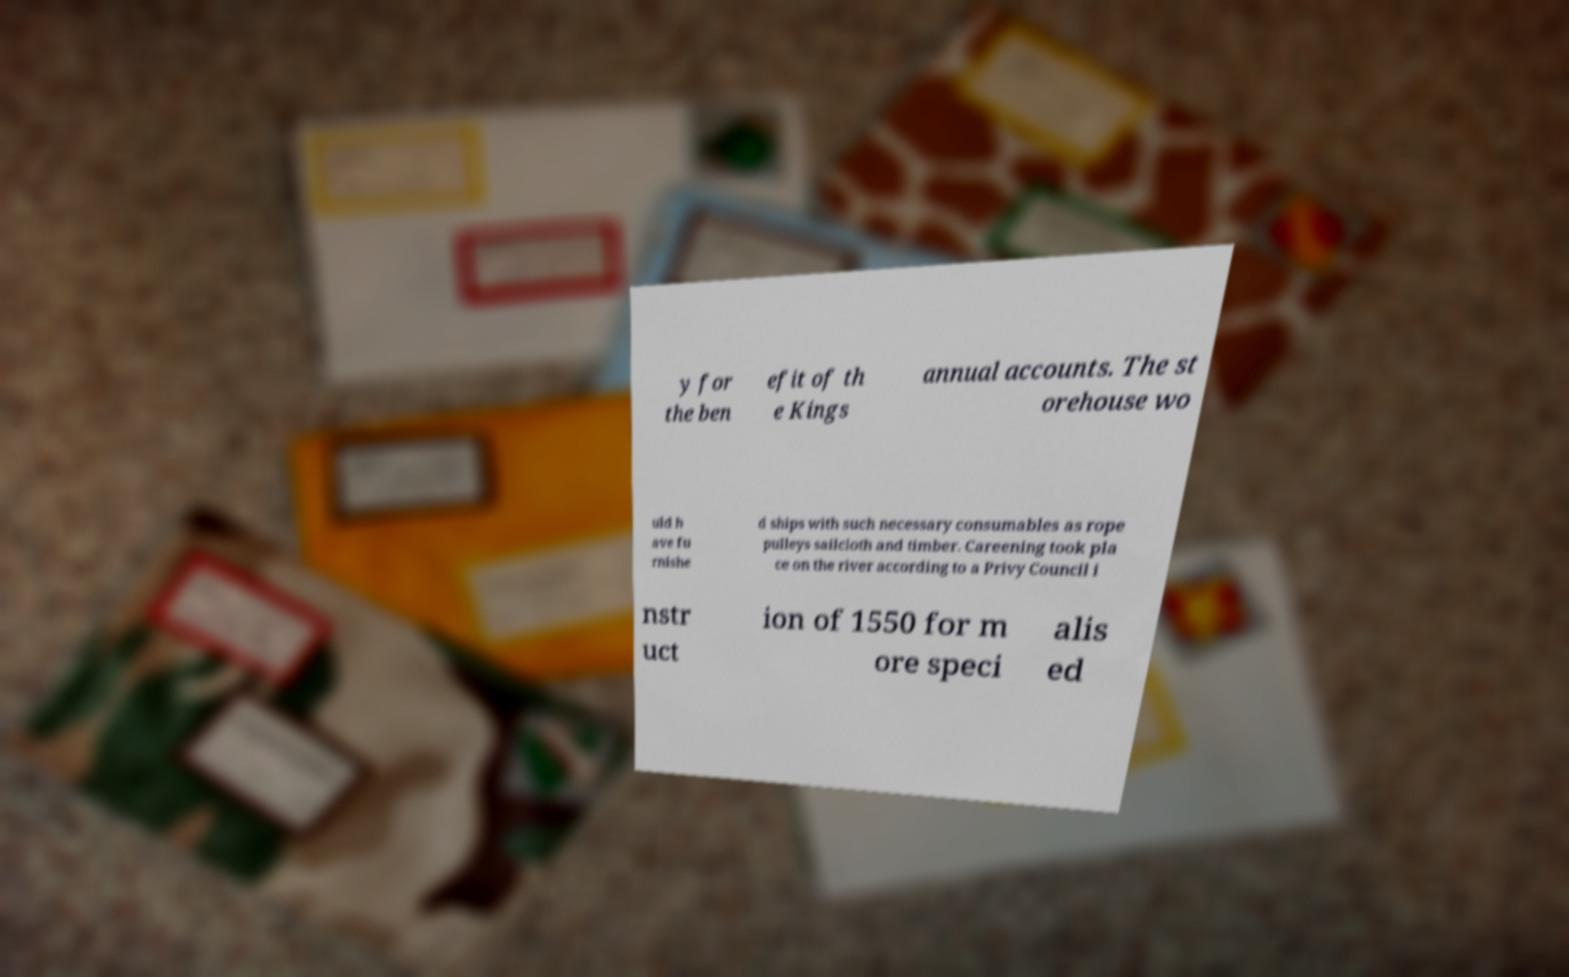For documentation purposes, I need the text within this image transcribed. Could you provide that? y for the ben efit of th e Kings annual accounts. The st orehouse wo uld h ave fu rnishe d ships with such necessary consumables as rope pulleys sailcloth and timber. Careening took pla ce on the river according to a Privy Council i nstr uct ion of 1550 for m ore speci alis ed 